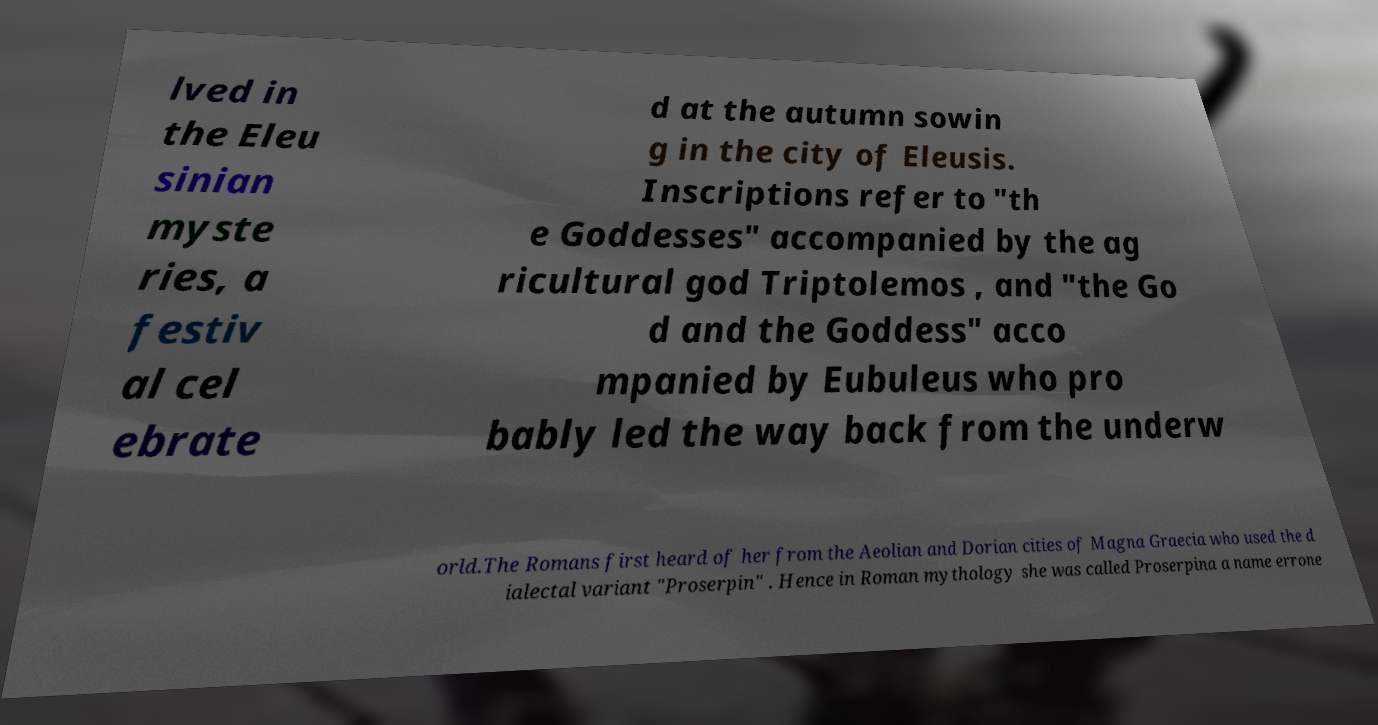What messages or text are displayed in this image? I need them in a readable, typed format. lved in the Eleu sinian myste ries, a festiv al cel ebrate d at the autumn sowin g in the city of Eleusis. Inscriptions refer to "th e Goddesses" accompanied by the ag ricultural god Triptolemos , and "the Go d and the Goddess" acco mpanied by Eubuleus who pro bably led the way back from the underw orld.The Romans first heard of her from the Aeolian and Dorian cities of Magna Graecia who used the d ialectal variant "Proserpin" . Hence in Roman mythology she was called Proserpina a name errone 